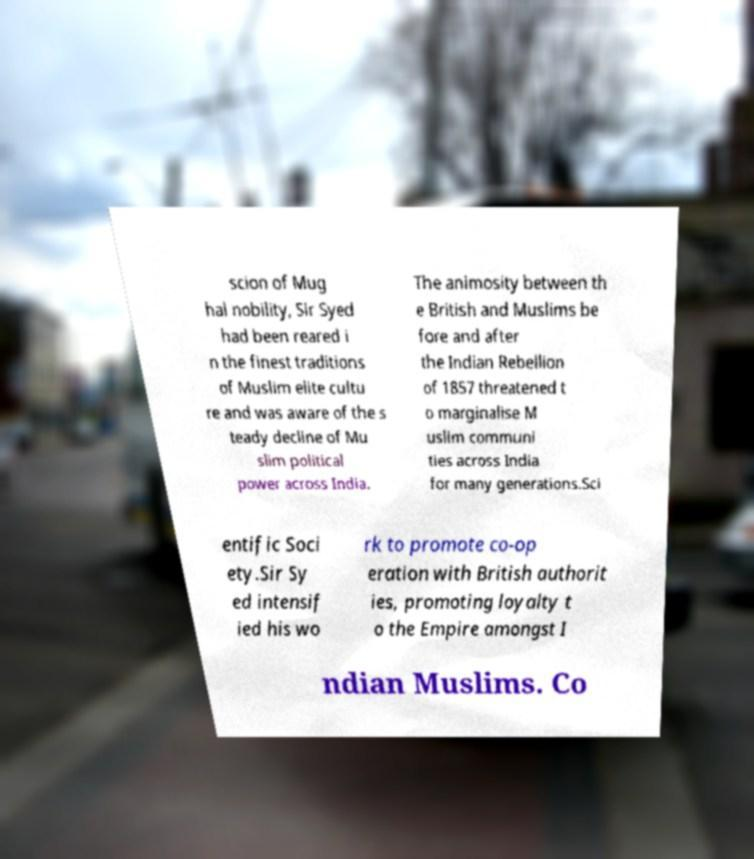Could you assist in decoding the text presented in this image and type it out clearly? scion of Mug hal nobility, Sir Syed had been reared i n the finest traditions of Muslim elite cultu re and was aware of the s teady decline of Mu slim political power across India. The animosity between th e British and Muslims be fore and after the Indian Rebellion of 1857 threatened t o marginalise M uslim communi ties across India for many generations.Sci entific Soci ety.Sir Sy ed intensif ied his wo rk to promote co-op eration with British authorit ies, promoting loyalty t o the Empire amongst I ndian Muslims. Co 